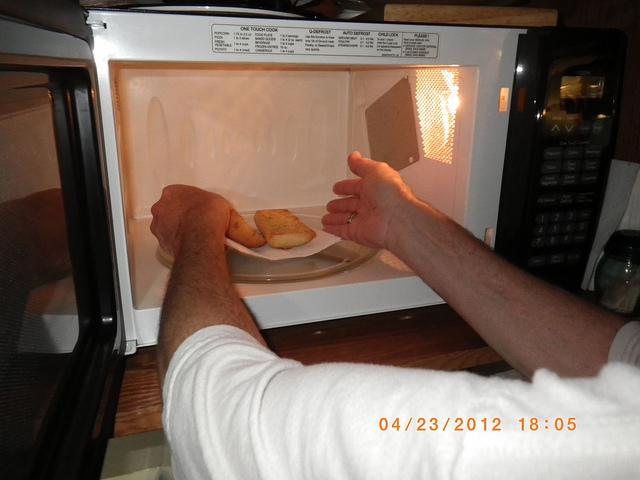What time is here?
Keep it brief. 18:05. Is this a microwave?
Answer briefly. Yes. What color is the paper plate in the microwave?
Write a very short answer. White. 